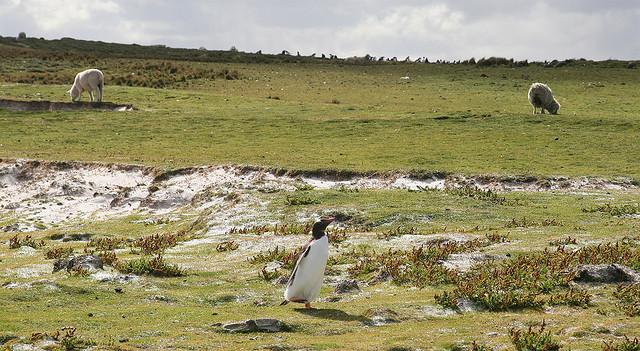Where do penguins and sheep cohabitate?
Short answer required. Australia. What animal is this?
Be succinct. Penguin. What are the sheep doing?
Write a very short answer. Grazing. Is that a dancing penguin?
Keep it brief. No. 